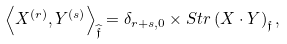Convert formula to latex. <formula><loc_0><loc_0><loc_500><loc_500>\left \langle X ^ { ( r ) } , Y ^ { ( s ) } \right \rangle _ { \widehat { \mathfrak { f } } } = \delta _ { r + s , 0 } \times S t r \left ( X \cdot Y \right ) _ { \mathfrak { f } } ,</formula> 